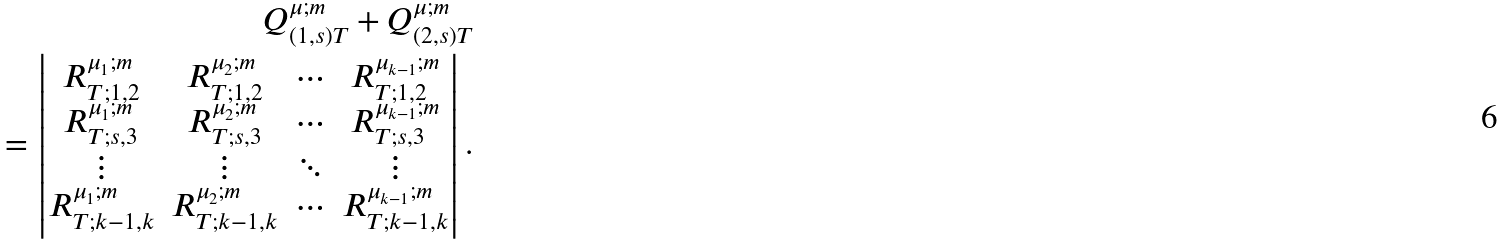<formula> <loc_0><loc_0><loc_500><loc_500>Q _ { ( 1 , s ) T } ^ { \mu ; m } + Q _ { ( 2 , s ) T } ^ { \mu ; m } \\ = \begin{vmatrix} R _ { T ; 1 , 2 } ^ { \mu _ { 1 } ; m } & R _ { T ; 1 , 2 } ^ { \mu _ { 2 } ; m } & \cdots & R _ { T ; 1 , 2 } ^ { \mu _ { k - 1 } ; m } \\ R _ { T ; s , 3 } ^ { \mu _ { 1 } ; m } & R _ { T ; s , 3 } ^ { \mu _ { 2 } ; m } & \cdots & R _ { T ; s , 3 } ^ { \mu _ { k - 1 } ; m } \\ \vdots & \vdots & \ddots & \vdots \\ R _ { T ; k - 1 , k } ^ { \mu _ { 1 } ; m } & R _ { T ; k - 1 , k } ^ { \mu _ { 2 } ; m } & \cdots & R _ { T ; k - 1 , k } ^ { \mu _ { k - 1 } ; m } \end{vmatrix} .</formula> 